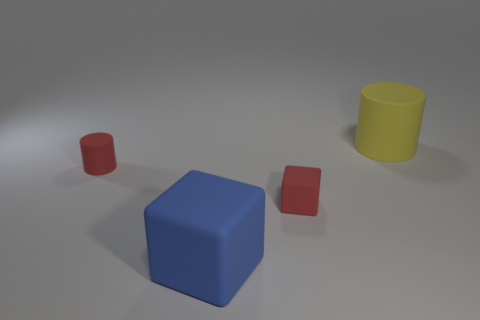There is a large yellow thing; is its shape the same as the object that is to the left of the big blue object?
Offer a terse response. Yes. What material is the small object left of the tiny red matte thing that is on the right side of the cylinder that is left of the big cylinder made of?
Provide a succinct answer. Rubber. What number of red matte cylinders are there?
Your response must be concise. 1. What number of blue objects are either large cylinders or matte blocks?
Offer a terse response. 1. There is a large matte object behind the big blue block; is its color the same as the big rubber thing on the left side of the large yellow object?
Make the answer very short. No. What number of tiny things are red matte cubes or matte cylinders?
Offer a very short reply. 2. The other rubber object that is the same shape as the big blue object is what size?
Offer a terse response. Small. Are there any other things that are the same size as the blue cube?
Your answer should be compact. Yes. There is a large object that is behind the big object that is to the left of the big yellow cylinder; what is it made of?
Your answer should be very brief. Rubber. How many matte things are tiny yellow things or small red cylinders?
Offer a terse response. 1. 